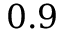Convert formula to latex. <formula><loc_0><loc_0><loc_500><loc_500>0 . 9</formula> 